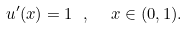<formula> <loc_0><loc_0><loc_500><loc_500>u ^ { \prime } ( x ) = 1 \ , \ \ x \in ( 0 , 1 ) .</formula> 